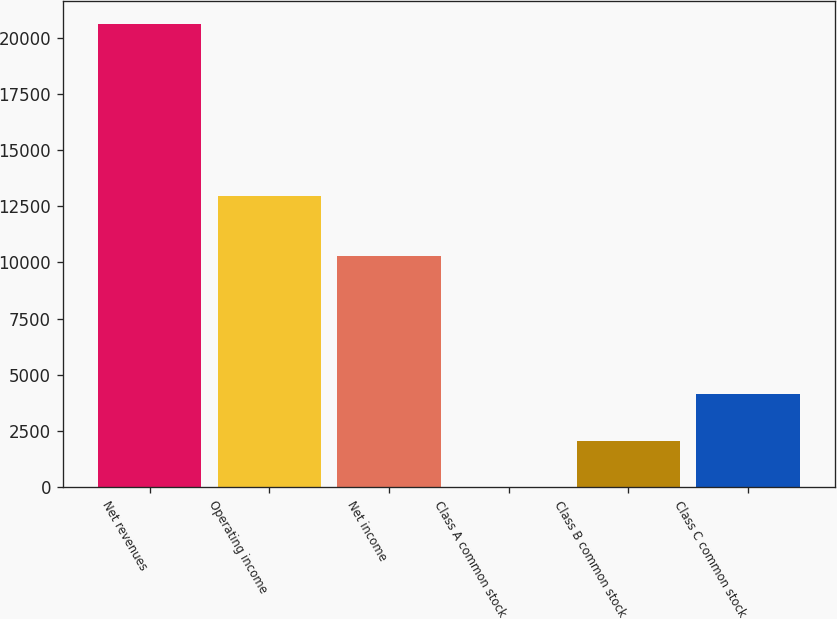Convert chart to OTSL. <chart><loc_0><loc_0><loc_500><loc_500><bar_chart><fcel>Net revenues<fcel>Operating income<fcel>Net income<fcel>Class A common stock<fcel>Class B common stock<fcel>Class C common stock<nl><fcel>20609<fcel>12954<fcel>10301<fcel>4.43<fcel>2064.89<fcel>4125.35<nl></chart> 